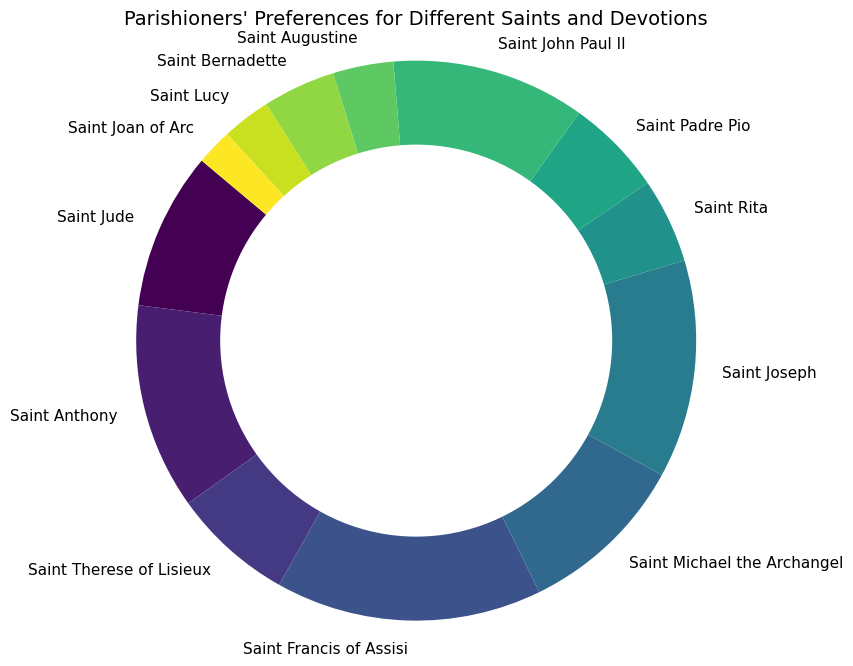Which Saint has the highest preference among the parishioners? By looking at the chart, we can see that Saint Francis of Assisi has the largest slice, indicating the highest preference.
Answer: Saint Francis of Assisi Which Saint has a higher preference: Saint Joseph or Saint Michael the Archangel? Comparing the sizes of their slices on the pie chart, Saint Joseph’s slice is larger than Saint Michael the Archangel’s slice.
Answer: Saint Joseph What is the combined preference percentage for Saint John Paul II and Saint John Paul II? Adding their individual percentages, which are seen on their respective slices: Saint Joseph (18%) and Saint John Paul II (16%) gives 18% + 16%.
Answer: 34% How many Saints have a preference percentage that is less than 5%? By observing the chart, the Saints with slices less than 5% are Saint Lucy, Saint Joan of Arc, and Saint Augustine.
Answer: 3 What is the difference in preference percentage between Saint Anthony and Saint Therese of Lisieux? Saint Anthony has a slice labeled 17%, and Saint Therese of Lisieux has a slice labeled 10%, so 17% - 10%.
Answer: 7% Which Saints have lower preferences compared to Saint Jude? Saints with smaller slices than the slice for Saint Jude (13%) are: Saint Therese of Lisieux (10%), Saint Rita (7%), Saint Padre Pio (8%), Saint John Paul II (16%), Saint Augustine (5%), Saint Bernadette (6%), Saint Lucy (4%), and Saint Joan of Arc (3%).
Answer: 8 Saints Which Saint's preference is closest to 10%? Looking at the pie chart, Saint Therese of Lisieux has a slice labeled exactly 10%.
Answer: Saint Therese of Lisieux What is the total preference percentage of all Saints other than Saint Francis of Assisi and Saint Anthony? The combined preference percentage for Saint Francis of Assisi and Saint Anthony is 22% + 17% = 39%, so subtracting from 100% gives 100% - 39%.
Answer: 61% What is the approximate average preference percentage per Saint? There are 13 different Saints, so we sum up the percentages of all the slices (13+17+10+22+14+18+7+8+16+5+6+4+3 = 143) and divide by 13, 143% ÷ 13.
Answer: 11% Which Saints have a preference percentage that falls between 10% and 20%? On the pie chart, the Saints with preference percentages between 10% and 20% are Saint Jude (13%), Saint Anthony (17%), Saint Michael the Archangel (14%), Saint Joseph (18%), and Saint John Paul II (16%).
Answer: 5 Saints 